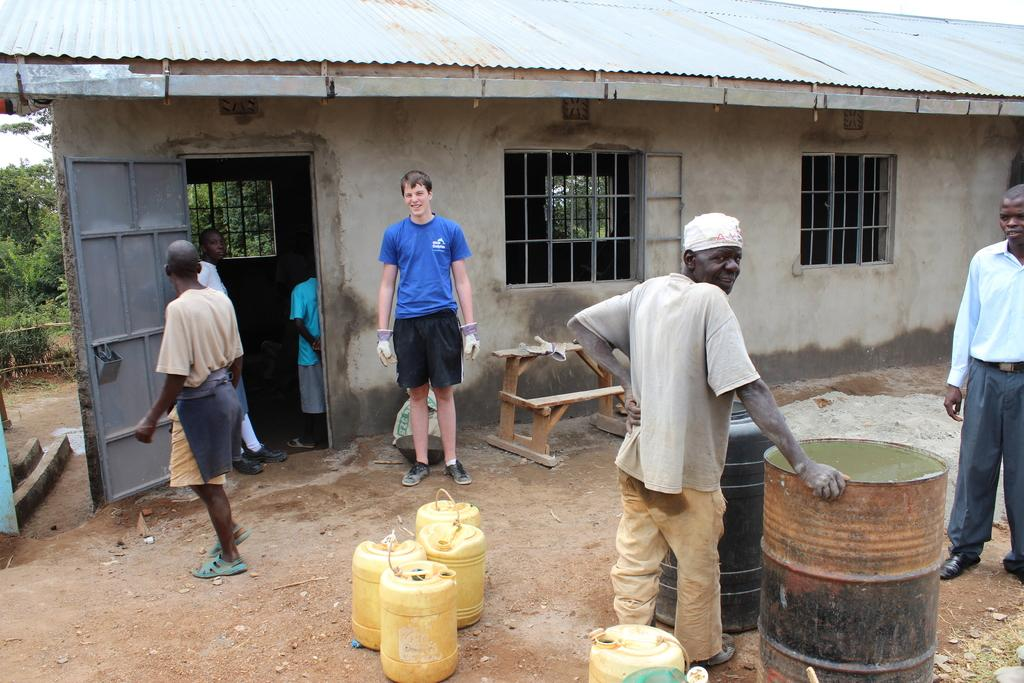What is the main subject in the middle of the image? There is a man standing in the middle of the image. What is the man wearing? The man is wearing a blue t-shirt. Who else is present in the image? There is another man standing on the right side of the image. What is the second man doing? The second man is placing his hand on a drum. What can be seen in the background of the image? There is a house under construction in the image. What type of shoe is the man wearing in the image? The facts provided do not mention any shoes, so we cannot determine the type of shoe the man is wearing. Where is the bedroom located in the image? There is no bedroom present in the image; it features a man standing in the middle, another man playing a drum, and a house under construction in the background. 